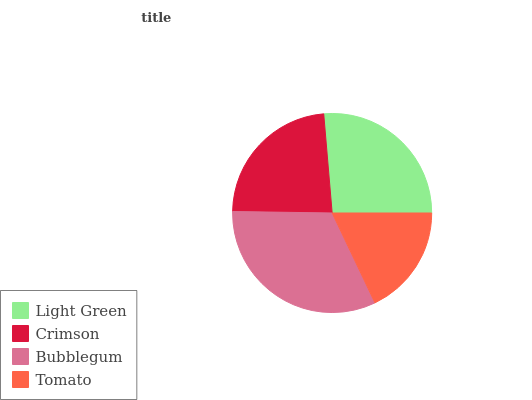Is Tomato the minimum?
Answer yes or no. Yes. Is Bubblegum the maximum?
Answer yes or no. Yes. Is Crimson the minimum?
Answer yes or no. No. Is Crimson the maximum?
Answer yes or no. No. Is Light Green greater than Crimson?
Answer yes or no. Yes. Is Crimson less than Light Green?
Answer yes or no. Yes. Is Crimson greater than Light Green?
Answer yes or no. No. Is Light Green less than Crimson?
Answer yes or no. No. Is Light Green the high median?
Answer yes or no. Yes. Is Crimson the low median?
Answer yes or no. Yes. Is Crimson the high median?
Answer yes or no. No. Is Light Green the low median?
Answer yes or no. No. 